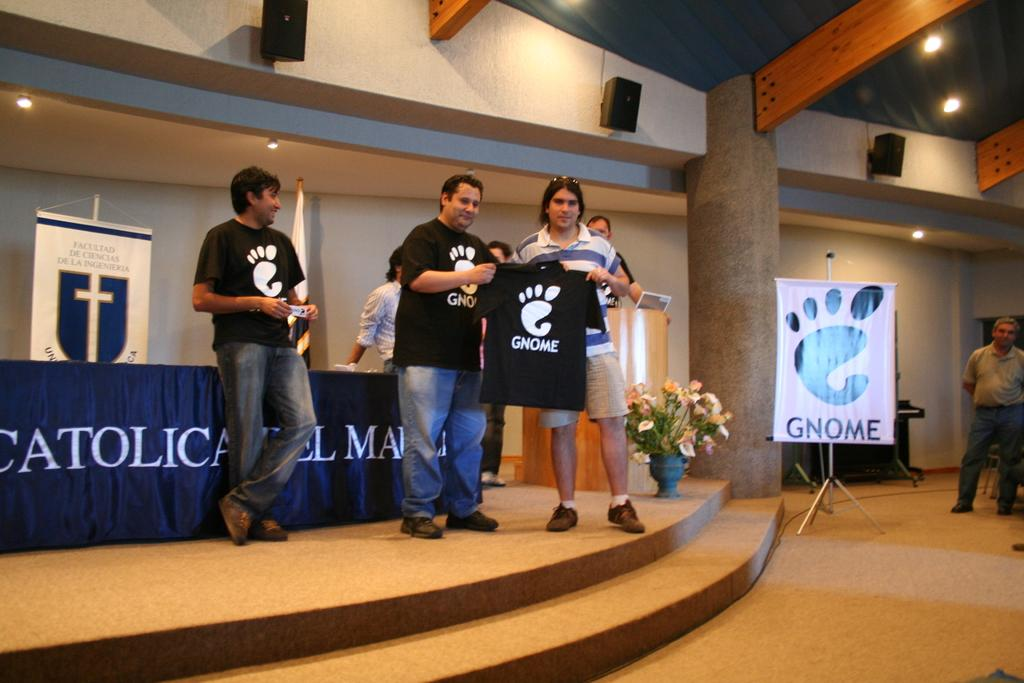<image>
Describe the image concisely. A group of people stand on the stage of a church wearing black Gnome t-shirts. 